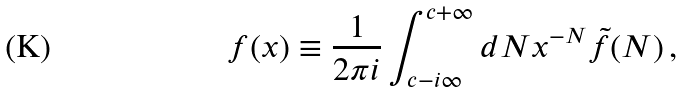Convert formula to latex. <formula><loc_0><loc_0><loc_500><loc_500>f ( x ) \equiv \frac { 1 } { 2 \pi i } \int _ { c - i \infty } ^ { c + \infty } d N x ^ { - N } { \tilde { f } } ( N ) \, ,</formula> 